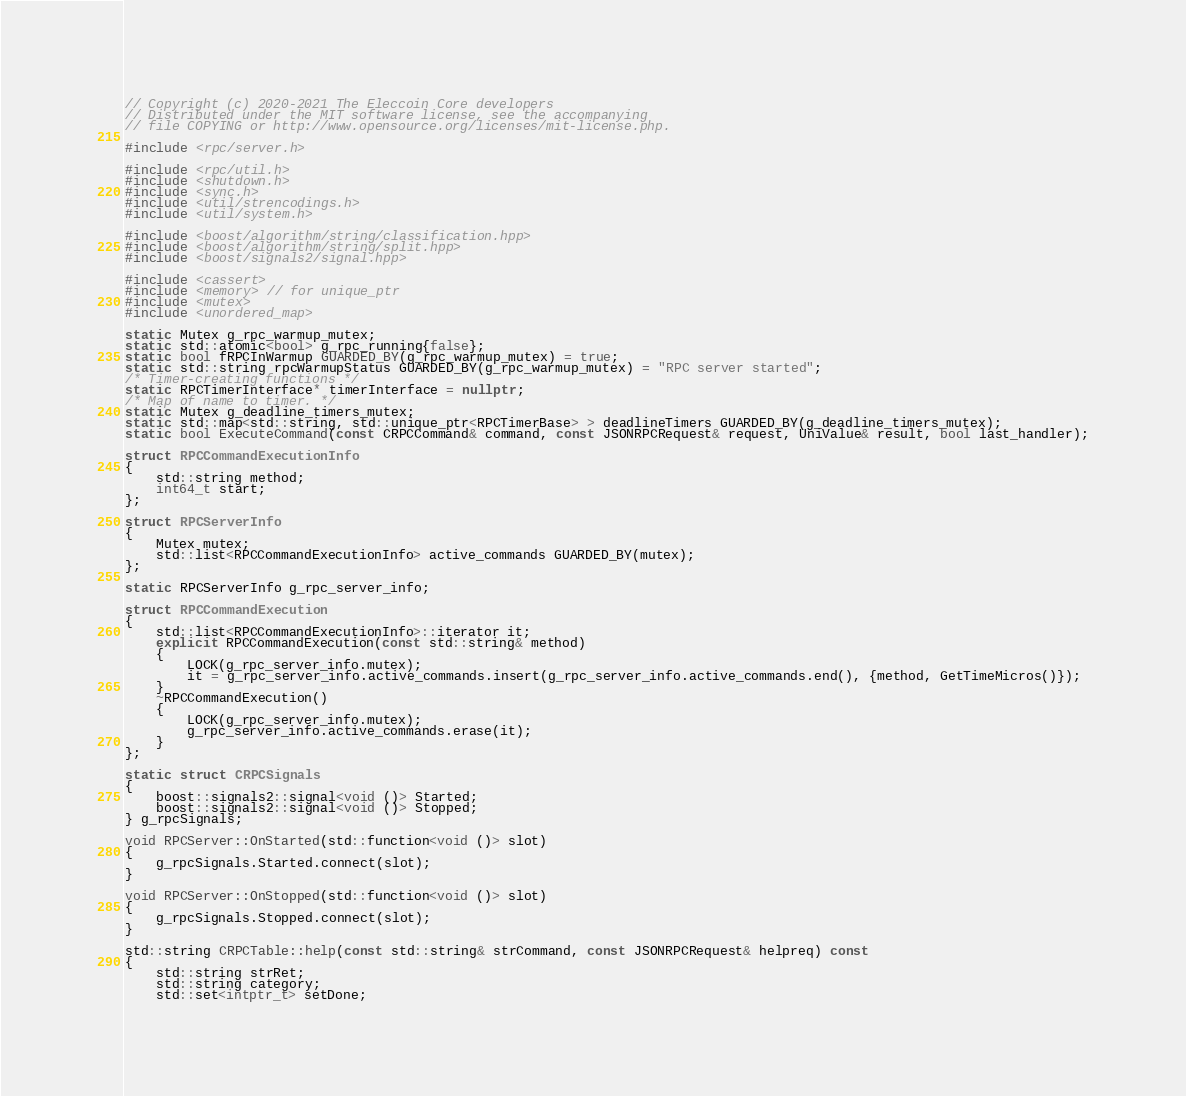Convert code to text. <code><loc_0><loc_0><loc_500><loc_500><_C++_>// Copyright (c) 2020-2021 The Eleccoin Core developers
// Distributed under the MIT software license, see the accompanying
// file COPYING or http://www.opensource.org/licenses/mit-license.php.

#include <rpc/server.h>

#include <rpc/util.h>
#include <shutdown.h>
#include <sync.h>
#include <util/strencodings.h>
#include <util/system.h>

#include <boost/algorithm/string/classification.hpp>
#include <boost/algorithm/string/split.hpp>
#include <boost/signals2/signal.hpp>

#include <cassert>
#include <memory> // for unique_ptr
#include <mutex>
#include <unordered_map>

static Mutex g_rpc_warmup_mutex;
static std::atomic<bool> g_rpc_running{false};
static bool fRPCInWarmup GUARDED_BY(g_rpc_warmup_mutex) = true;
static std::string rpcWarmupStatus GUARDED_BY(g_rpc_warmup_mutex) = "RPC server started";
/* Timer-creating functions */
static RPCTimerInterface* timerInterface = nullptr;
/* Map of name to timer. */
static Mutex g_deadline_timers_mutex;
static std::map<std::string, std::unique_ptr<RPCTimerBase> > deadlineTimers GUARDED_BY(g_deadline_timers_mutex);
static bool ExecuteCommand(const CRPCCommand& command, const JSONRPCRequest& request, UniValue& result, bool last_handler);

struct RPCCommandExecutionInfo
{
    std::string method;
    int64_t start;
};

struct RPCServerInfo
{
    Mutex mutex;
    std::list<RPCCommandExecutionInfo> active_commands GUARDED_BY(mutex);
};

static RPCServerInfo g_rpc_server_info;

struct RPCCommandExecution
{
    std::list<RPCCommandExecutionInfo>::iterator it;
    explicit RPCCommandExecution(const std::string& method)
    {
        LOCK(g_rpc_server_info.mutex);
        it = g_rpc_server_info.active_commands.insert(g_rpc_server_info.active_commands.end(), {method, GetTimeMicros()});
    }
    ~RPCCommandExecution()
    {
        LOCK(g_rpc_server_info.mutex);
        g_rpc_server_info.active_commands.erase(it);
    }
};

static struct CRPCSignals
{
    boost::signals2::signal<void ()> Started;
    boost::signals2::signal<void ()> Stopped;
} g_rpcSignals;

void RPCServer::OnStarted(std::function<void ()> slot)
{
    g_rpcSignals.Started.connect(slot);
}

void RPCServer::OnStopped(std::function<void ()> slot)
{
    g_rpcSignals.Stopped.connect(slot);
}

std::string CRPCTable::help(const std::string& strCommand, const JSONRPCRequest& helpreq) const
{
    std::string strRet;
    std::string category;
    std::set<intptr_t> setDone;</code> 